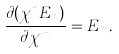<formula> <loc_0><loc_0><loc_500><loc_500>\frac { \partial ( \chi ^ { n } E _ { n } ) } { \partial \chi ^ { m } } = E _ { m } .</formula> 